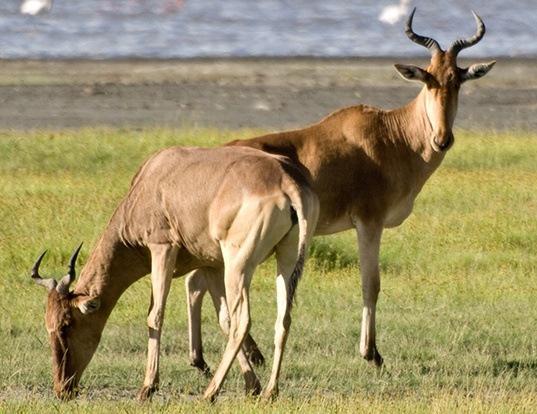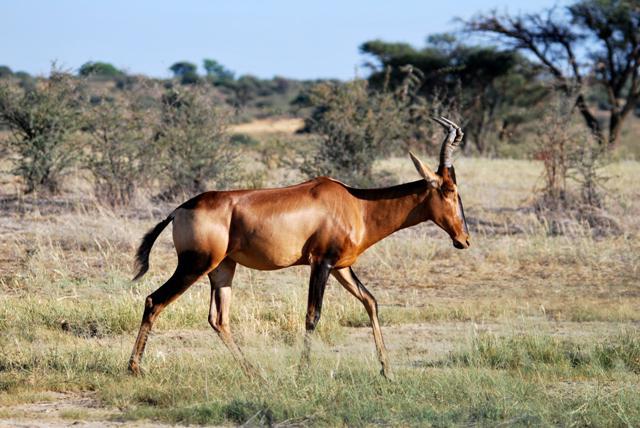The first image is the image on the left, the second image is the image on the right. Assess this claim about the two images: "An image shows exactly two antelope that are not sparring.". Correct or not? Answer yes or no. Yes. 